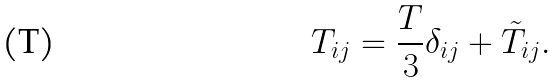Convert formula to latex. <formula><loc_0><loc_0><loc_500><loc_500>T _ { i j } = \frac { T } { 3 } \delta _ { i j } + \tilde { T } _ { i j } .</formula> 